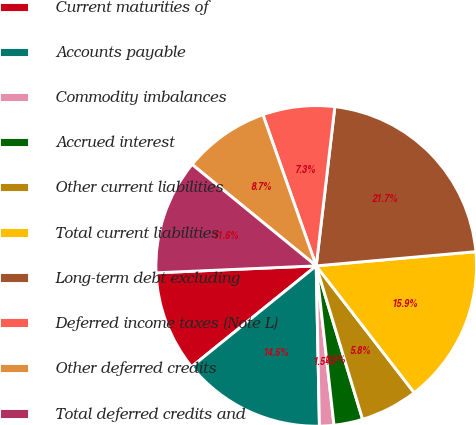Convert chart. <chart><loc_0><loc_0><loc_500><loc_500><pie_chart><fcel>Current maturities of<fcel>Accounts payable<fcel>Commodity imbalances<fcel>Accrued interest<fcel>Other current liabilities<fcel>Total current liabilities<fcel>Long-term debt excluding<fcel>Deferred income taxes (Note L)<fcel>Other deferred credits<fcel>Total deferred credits and<nl><fcel>10.14%<fcel>14.49%<fcel>1.45%<fcel>2.9%<fcel>5.8%<fcel>15.94%<fcel>21.73%<fcel>7.25%<fcel>8.7%<fcel>11.59%<nl></chart> 